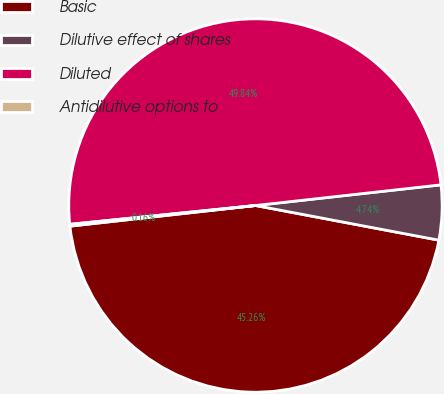Convert chart to OTSL. <chart><loc_0><loc_0><loc_500><loc_500><pie_chart><fcel>Basic<fcel>Dilutive effect of shares<fcel>Diluted<fcel>Antidilutive options to<nl><fcel>45.26%<fcel>4.74%<fcel>49.84%<fcel>0.16%<nl></chart> 